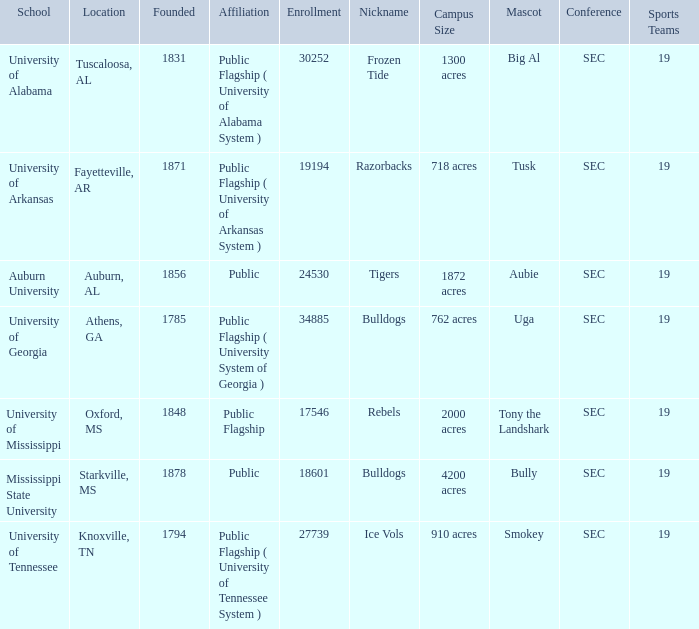Could you parse the entire table as a dict? {'header': ['School', 'Location', 'Founded', 'Affiliation', 'Enrollment', 'Nickname', 'Campus Size', 'Mascot', 'Conference', 'Sports Teams'], 'rows': [['University of Alabama', 'Tuscaloosa, AL', '1831', 'Public Flagship ( University of Alabama System )', '30252', 'Frozen Tide', '1300 acres', 'Big Al', 'SEC', '19'], ['University of Arkansas', 'Fayetteville, AR', '1871', 'Public Flagship ( University of Arkansas System )', '19194', 'Razorbacks', '718 acres', 'Tusk', 'SEC', '19'], ['Auburn University', 'Auburn, AL', '1856', 'Public', '24530', 'Tigers', '1872 acres', 'Aubie', 'SEC', '19'], ['University of Georgia', 'Athens, GA', '1785', 'Public Flagship ( University System of Georgia )', '34885', 'Bulldogs', '762 acres', 'Uga', 'SEC', '19'], ['University of Mississippi', 'Oxford, MS', '1848', 'Public Flagship', '17546', 'Rebels', '2000 acres', 'Tony the Landshark', 'SEC', '19'], ['Mississippi State University', 'Starkville, MS', '1878', 'Public', '18601', 'Bulldogs', '4200 acres', 'Bully', 'SEC', '19'], ['University of Tennessee', 'Knoxville, TN', '1794', 'Public Flagship ( University of Tennessee System )', '27739', 'Ice Vols', '910 acres', 'Smokey', 'SEC', '19']]} What is the maximum enrollment of the schools? 34885.0. 